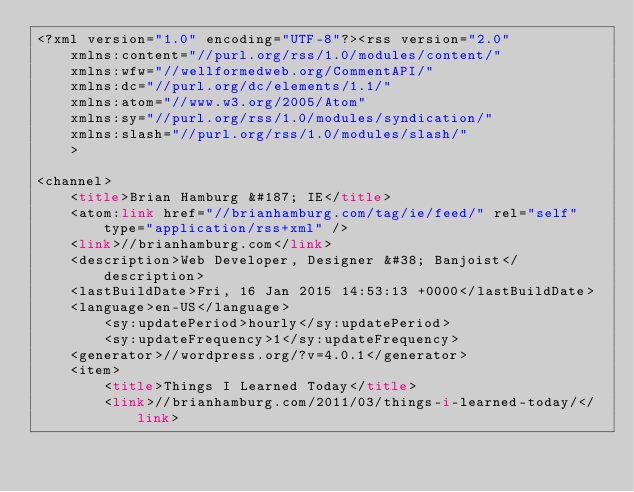Convert code to text. <code><loc_0><loc_0><loc_500><loc_500><_HTML_><?xml version="1.0" encoding="UTF-8"?><rss version="2.0"
	xmlns:content="//purl.org/rss/1.0/modules/content/"
	xmlns:wfw="//wellformedweb.org/CommentAPI/"
	xmlns:dc="//purl.org/dc/elements/1.1/"
	xmlns:atom="//www.w3.org/2005/Atom"
	xmlns:sy="//purl.org/rss/1.0/modules/syndication/"
	xmlns:slash="//purl.org/rss/1.0/modules/slash/"
	>

<channel>
	<title>Brian Hamburg &#187; IE</title>
	<atom:link href="//brianhamburg.com/tag/ie/feed/" rel="self" type="application/rss+xml" />
	<link>//brianhamburg.com</link>
	<description>Web Developer, Designer &#38; Banjoist</description>
	<lastBuildDate>Fri, 16 Jan 2015 14:53:13 +0000</lastBuildDate>
	<language>en-US</language>
		<sy:updatePeriod>hourly</sy:updatePeriod>
		<sy:updateFrequency>1</sy:updateFrequency>
	<generator>//wordpress.org/?v=4.0.1</generator>
	<item>
		<title>Things I Learned Today</title>
		<link>//brianhamburg.com/2011/03/things-i-learned-today/</link></code> 